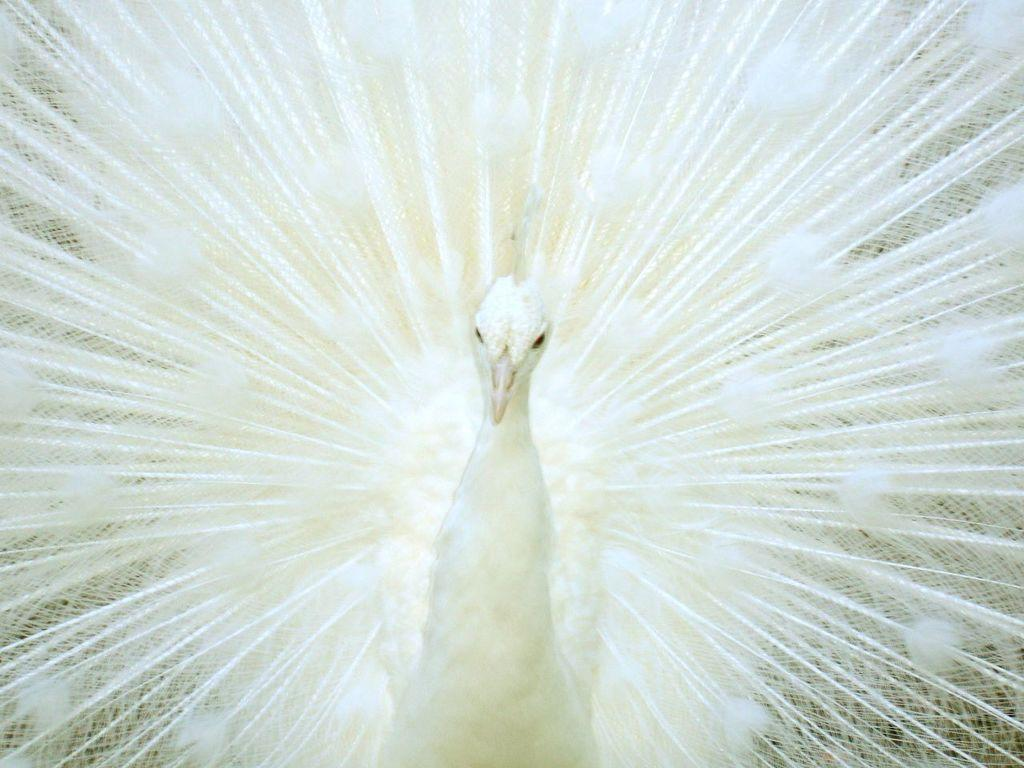What type of bird is in the image? There is a white peacock in the image. How close is the peacock to the viewer? The peacock is close to the viewer. What feature of the peacock is mentioned in the facts? The peacock has feathers. What type of flame can be seen near the peacock's feet in the image? There is no flame present in the image; it features a white peacock. How many brothers does the peacock have in the image? There is no mention of any brothers in the image, as it only features a white peacock. 